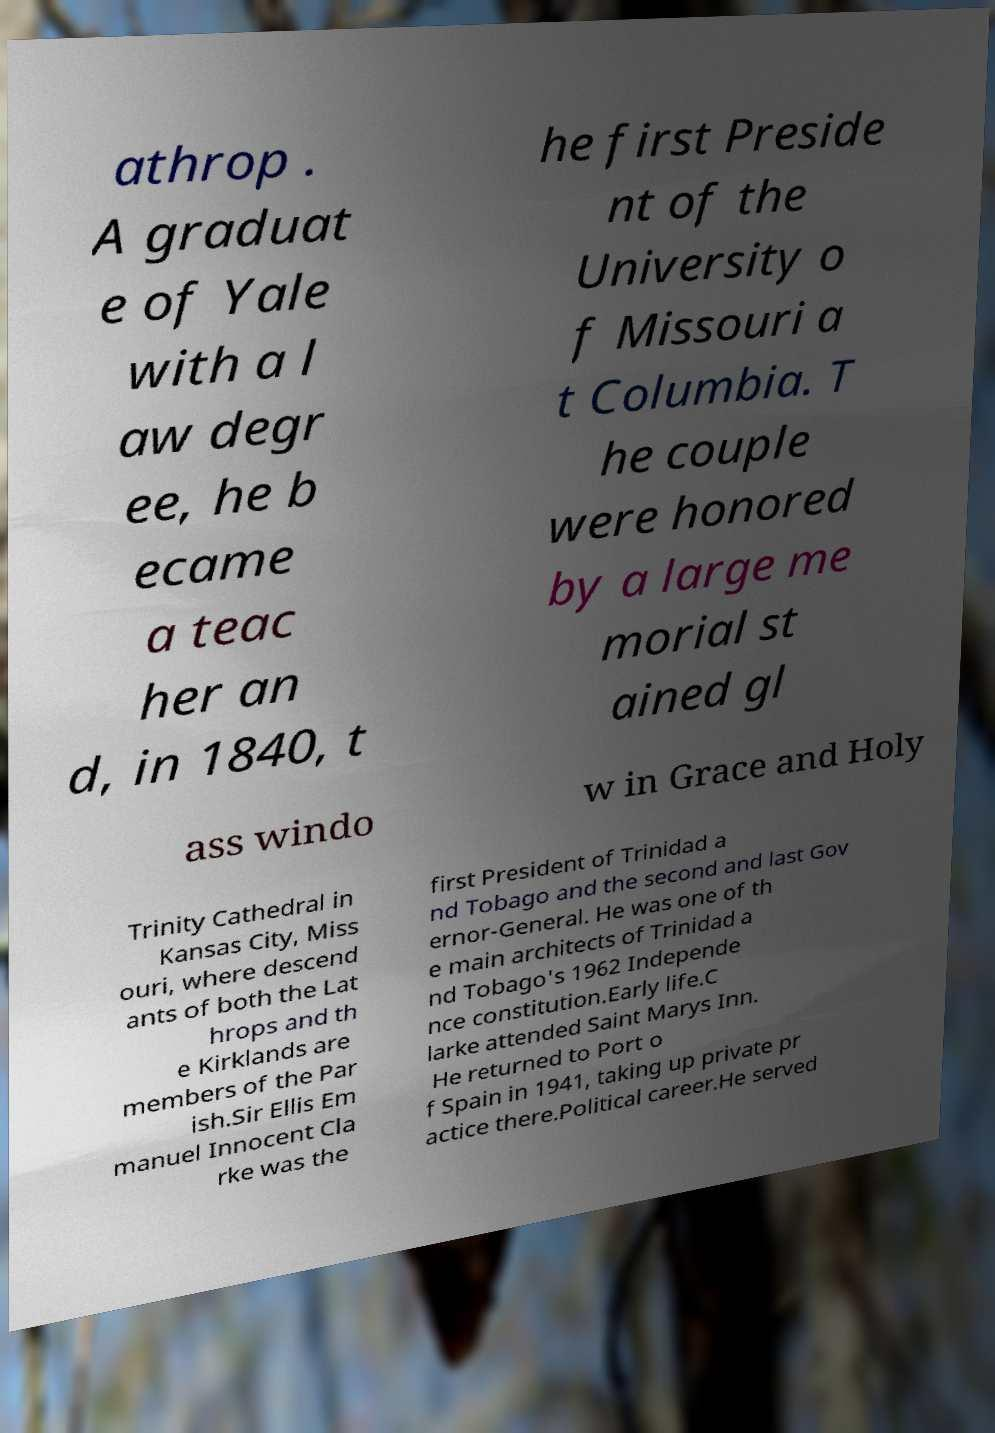There's text embedded in this image that I need extracted. Can you transcribe it verbatim? athrop . A graduat e of Yale with a l aw degr ee, he b ecame a teac her an d, in 1840, t he first Preside nt of the University o f Missouri a t Columbia. T he couple were honored by a large me morial st ained gl ass windo w in Grace and Holy Trinity Cathedral in Kansas City, Miss ouri, where descend ants of both the Lat hrops and th e Kirklands are members of the Par ish.Sir Ellis Em manuel Innocent Cla rke was the first President of Trinidad a nd Tobago and the second and last Gov ernor-General. He was one of th e main architects of Trinidad a nd Tobago's 1962 Independe nce constitution.Early life.C larke attended Saint Marys Inn. He returned to Port o f Spain in 1941, taking up private pr actice there.Political career.He served 